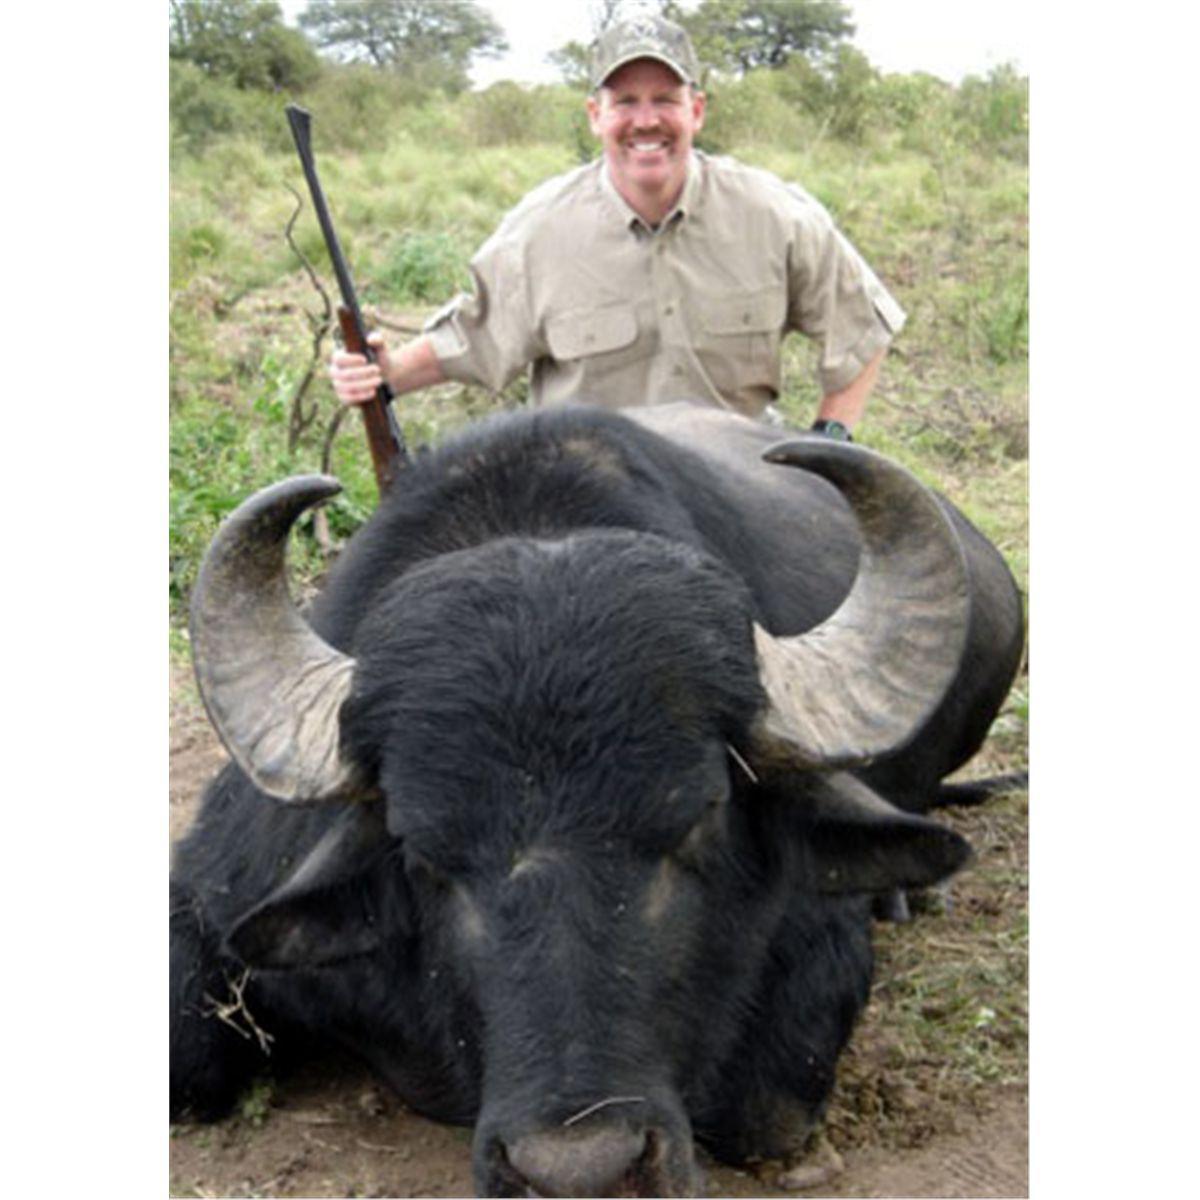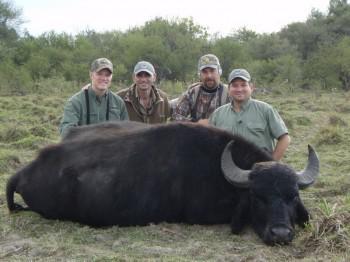The first image is the image on the left, the second image is the image on the right. Assess this claim about the two images: "The left image contains three humans posing with a dead water buffalo.". Correct or not? Answer yes or no. No. The first image is the image on the left, the second image is the image on the right. Examine the images to the left and right. Is the description "Three hunters with one gun pose behind a downed water buffalo in one image, and one man poses with his weapon and a dead water buffalo in the other image." accurate? Answer yes or no. No. 